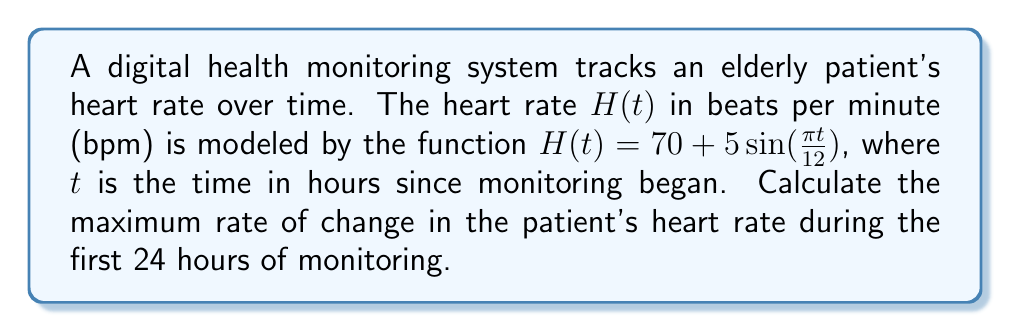Help me with this question. To find the maximum rate of change in the patient's heart rate, we need to follow these steps:

1) First, we need to find the derivative of the heart rate function $H(t)$. This will give us the rate of change at any given time.

   $$\frac{dH}{dt} = \frac{d}{dt}[70 + 5\sin(\frac{\pi t}{12})]$$
   $$\frac{dH}{dt} = 5 \cdot \frac{\pi}{12} \cos(\frac{\pi t}{12})$$
   $$\frac{dH}{dt} = \frac{5\pi}{12} \cos(\frac{\pi t}{12})$$

2) The maximum rate of change will occur when $\cos(\frac{\pi t}{12})$ is at its maximum value, which is 1.

3) Therefore, the maximum rate of change is:

   $$\text{Max }\frac{dH}{dt} = \frac{5\pi}{12} \approx 1.309$$

4) To interpret this result, we can say that the maximum rate of change is approximately 1.309 bpm per hour, or about 1.309 beats per minute squared.

5) Note that this maximum rate of change occurs periodically, specifically when $\frac{\pi t}{12} = 2\pi n$ for integer $n$, which corresponds to $t = 24n$ hours. This means the maximum rate of change occurs at the start of monitoring and every 24 hours thereafter.

This analysis provides valuable information for digital health monitoring systems, allowing for the detection of rapid changes in heart rate that might require immediate attention in elderly care.
Answer: The maximum rate of change in the patient's heart rate is $\frac{5\pi}{12} \approx 1.309$ beats per minute per hour. 